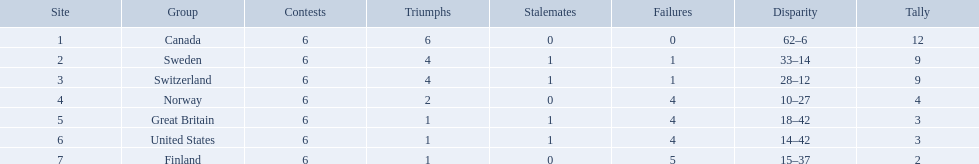Which are the two countries? Switzerland, Great Britain. What were the point totals for each of these countries? 9, 3. Of these point totals, which is better? 9. Which country earned this point total? Switzerland. What are the names of the countries? Canada, Sweden, Switzerland, Norway, Great Britain, United States, Finland. How many wins did switzerland have? 4. How many wins did great britain have? 1. Which country had more wins, great britain or switzerland? Switzerland. 